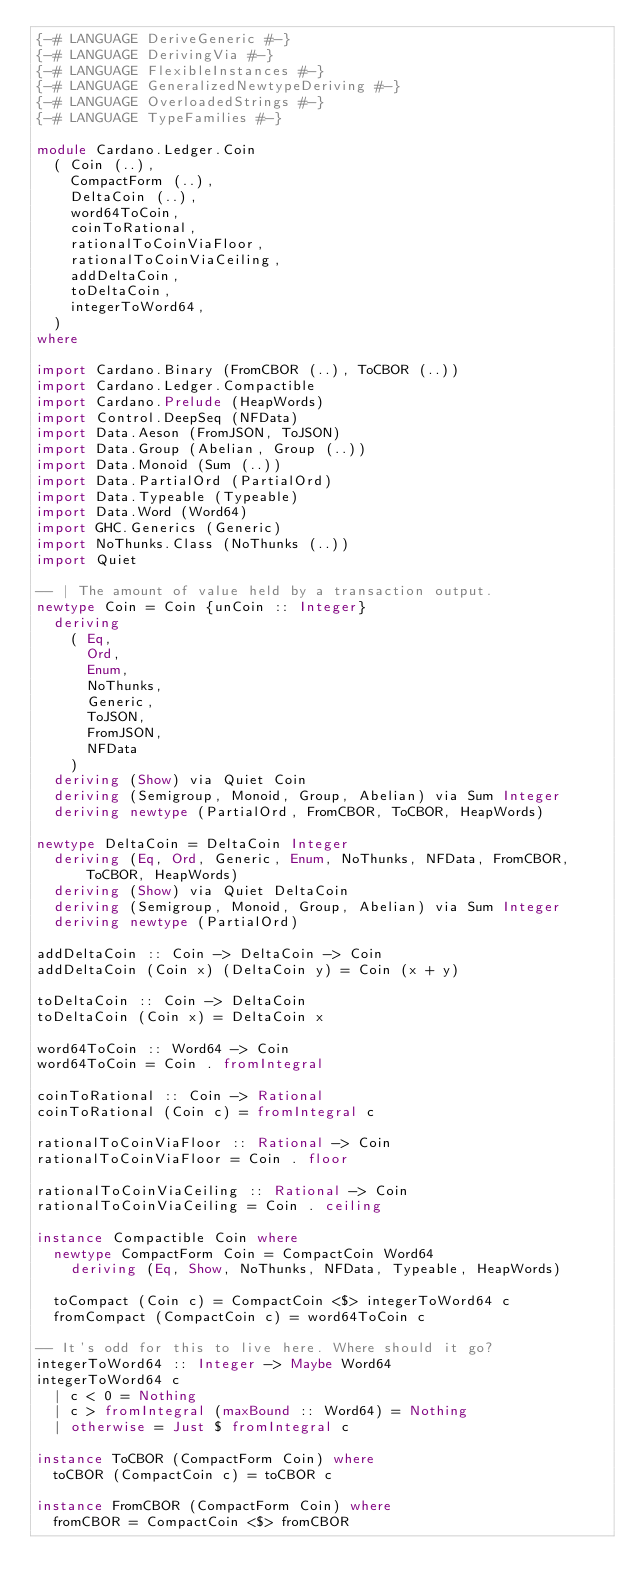Convert code to text. <code><loc_0><loc_0><loc_500><loc_500><_Haskell_>{-# LANGUAGE DeriveGeneric #-}
{-# LANGUAGE DerivingVia #-}
{-# LANGUAGE FlexibleInstances #-}
{-# LANGUAGE GeneralizedNewtypeDeriving #-}
{-# LANGUAGE OverloadedStrings #-}
{-# LANGUAGE TypeFamilies #-}

module Cardano.Ledger.Coin
  ( Coin (..),
    CompactForm (..),
    DeltaCoin (..),
    word64ToCoin,
    coinToRational,
    rationalToCoinViaFloor,
    rationalToCoinViaCeiling,
    addDeltaCoin,
    toDeltaCoin,
    integerToWord64,
  )
where

import Cardano.Binary (FromCBOR (..), ToCBOR (..))
import Cardano.Ledger.Compactible
import Cardano.Prelude (HeapWords)
import Control.DeepSeq (NFData)
import Data.Aeson (FromJSON, ToJSON)
import Data.Group (Abelian, Group (..))
import Data.Monoid (Sum (..))
import Data.PartialOrd (PartialOrd)
import Data.Typeable (Typeable)
import Data.Word (Word64)
import GHC.Generics (Generic)
import NoThunks.Class (NoThunks (..))
import Quiet

-- | The amount of value held by a transaction output.
newtype Coin = Coin {unCoin :: Integer}
  deriving
    ( Eq,
      Ord,
      Enum,
      NoThunks,
      Generic,
      ToJSON,
      FromJSON,
      NFData
    )
  deriving (Show) via Quiet Coin
  deriving (Semigroup, Monoid, Group, Abelian) via Sum Integer
  deriving newtype (PartialOrd, FromCBOR, ToCBOR, HeapWords)

newtype DeltaCoin = DeltaCoin Integer
  deriving (Eq, Ord, Generic, Enum, NoThunks, NFData, FromCBOR, ToCBOR, HeapWords)
  deriving (Show) via Quiet DeltaCoin
  deriving (Semigroup, Monoid, Group, Abelian) via Sum Integer
  deriving newtype (PartialOrd)

addDeltaCoin :: Coin -> DeltaCoin -> Coin
addDeltaCoin (Coin x) (DeltaCoin y) = Coin (x + y)

toDeltaCoin :: Coin -> DeltaCoin
toDeltaCoin (Coin x) = DeltaCoin x

word64ToCoin :: Word64 -> Coin
word64ToCoin = Coin . fromIntegral

coinToRational :: Coin -> Rational
coinToRational (Coin c) = fromIntegral c

rationalToCoinViaFloor :: Rational -> Coin
rationalToCoinViaFloor = Coin . floor

rationalToCoinViaCeiling :: Rational -> Coin
rationalToCoinViaCeiling = Coin . ceiling

instance Compactible Coin where
  newtype CompactForm Coin = CompactCoin Word64
    deriving (Eq, Show, NoThunks, NFData, Typeable, HeapWords)

  toCompact (Coin c) = CompactCoin <$> integerToWord64 c
  fromCompact (CompactCoin c) = word64ToCoin c

-- It's odd for this to live here. Where should it go?
integerToWord64 :: Integer -> Maybe Word64
integerToWord64 c
  | c < 0 = Nothing
  | c > fromIntegral (maxBound :: Word64) = Nothing
  | otherwise = Just $ fromIntegral c

instance ToCBOR (CompactForm Coin) where
  toCBOR (CompactCoin c) = toCBOR c

instance FromCBOR (CompactForm Coin) where
  fromCBOR = CompactCoin <$> fromCBOR
</code> 